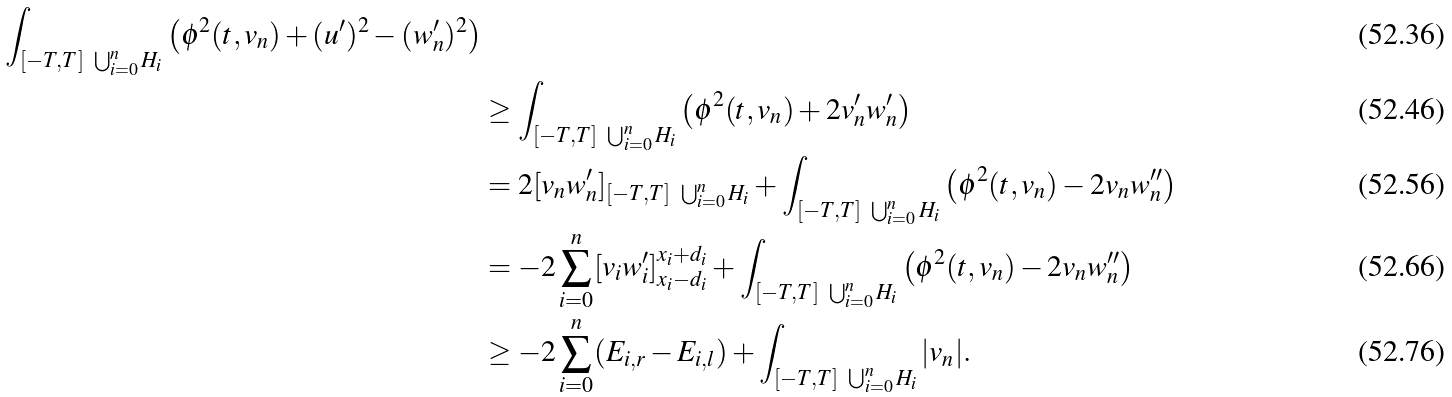<formula> <loc_0><loc_0><loc_500><loc_500>{ \int _ { [ - T , T ] \ \bigcup _ { i = 0 } ^ { n } H _ { i } } \left ( \phi ^ { 2 } ( t , v _ { n } ) + ( u ^ { \prime } ) ^ { 2 } - ( w _ { n } ^ { \prime } ) ^ { 2 } \right ) } \\ & \geq \int _ { [ - T , T ] \ \bigcup _ { i = 0 } ^ { n } H _ { i } } \left ( \phi ^ { 2 } ( t , v _ { n } ) + 2 v _ { n } ^ { \prime } w _ { n } ^ { \prime } \right ) \\ & = 2 [ v _ { n } w _ { n } ^ { \prime } ] _ { [ - T , T ] \ \bigcup _ { i = 0 } ^ { n } H _ { i } } + \int _ { [ - T , T ] \ \bigcup _ { i = 0 } ^ { n } H _ { i } } \left ( \phi ^ { 2 } ( t , v _ { n } ) - 2 v _ { n } w _ { n } ^ { \prime \prime } \right ) \\ & = - 2 \sum _ { i = 0 } ^ { n } [ v _ { i } w _ { i } ^ { \prime } ] _ { x _ { i } - d _ { i } } ^ { x _ { i } + d _ { i } } + \int _ { [ - T , T ] \ \bigcup _ { i = 0 } ^ { n } H _ { i } } \left ( \phi ^ { 2 } ( t , v _ { n } ) - 2 v _ { n } w _ { n } ^ { \prime \prime } \right ) \\ & \geq - 2 \sum _ { i = 0 } ^ { n } ( E _ { i , r } - E _ { i , l } ) + \int _ { [ - T , T ] \ \bigcup _ { i = 0 } ^ { n } H _ { i } } | v _ { n } | .</formula> 